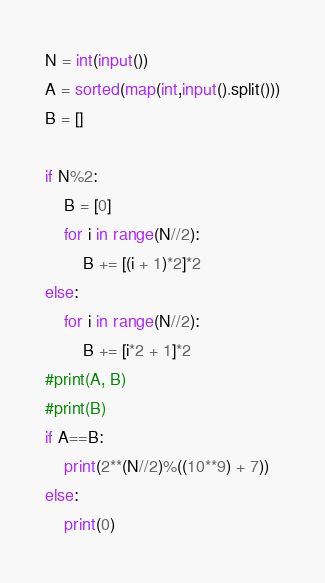Convert code to text. <code><loc_0><loc_0><loc_500><loc_500><_Python_>N = int(input())
A = sorted(map(int,input().split()))
B = []

if N%2:
	B = [0]
	for i in range(N//2):
		B += [(i + 1)*2]*2
else:
	for i in range(N//2):
		B += [i*2 + 1]*2	
#print(A, B)
#print(B)
if A==B:
	print(2**(N//2)%((10**9) + 7))
else:
	print(0)


</code> 